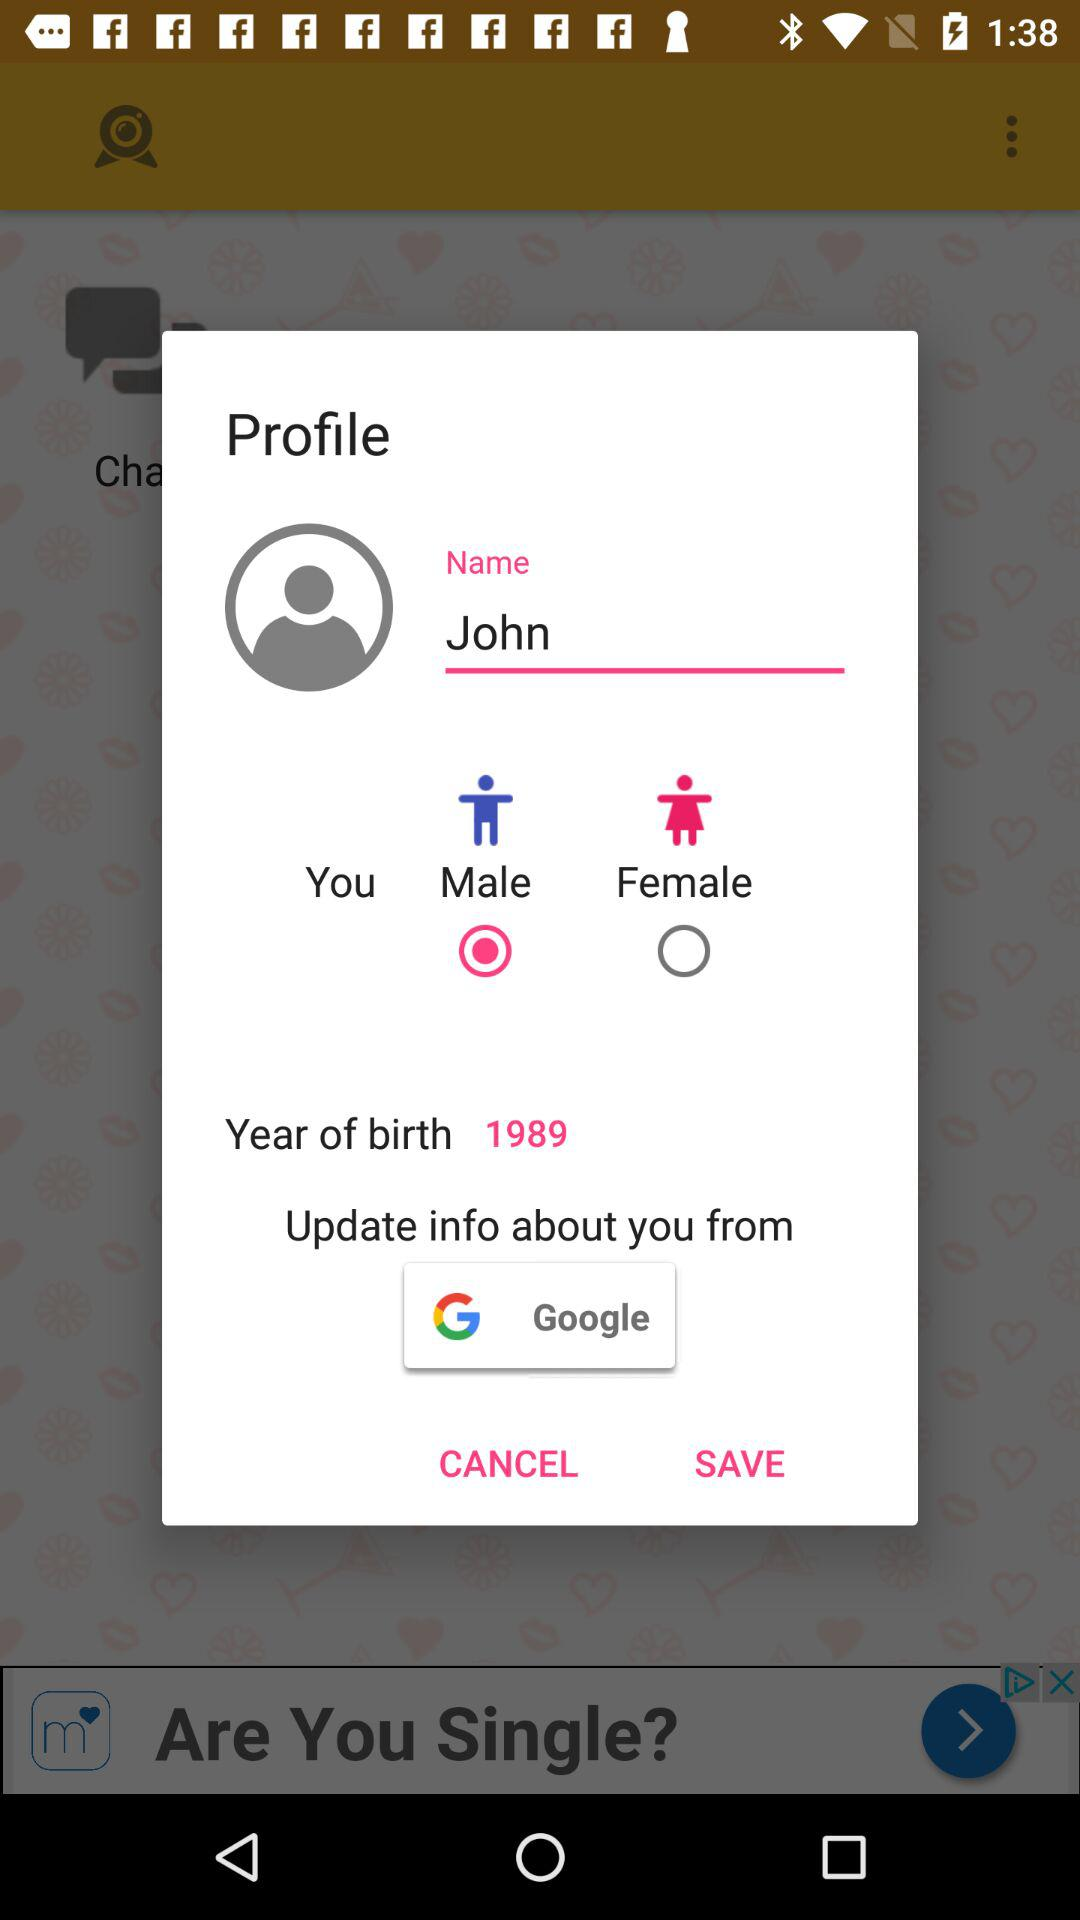What is the year of birth? The year of birth is 1989. 